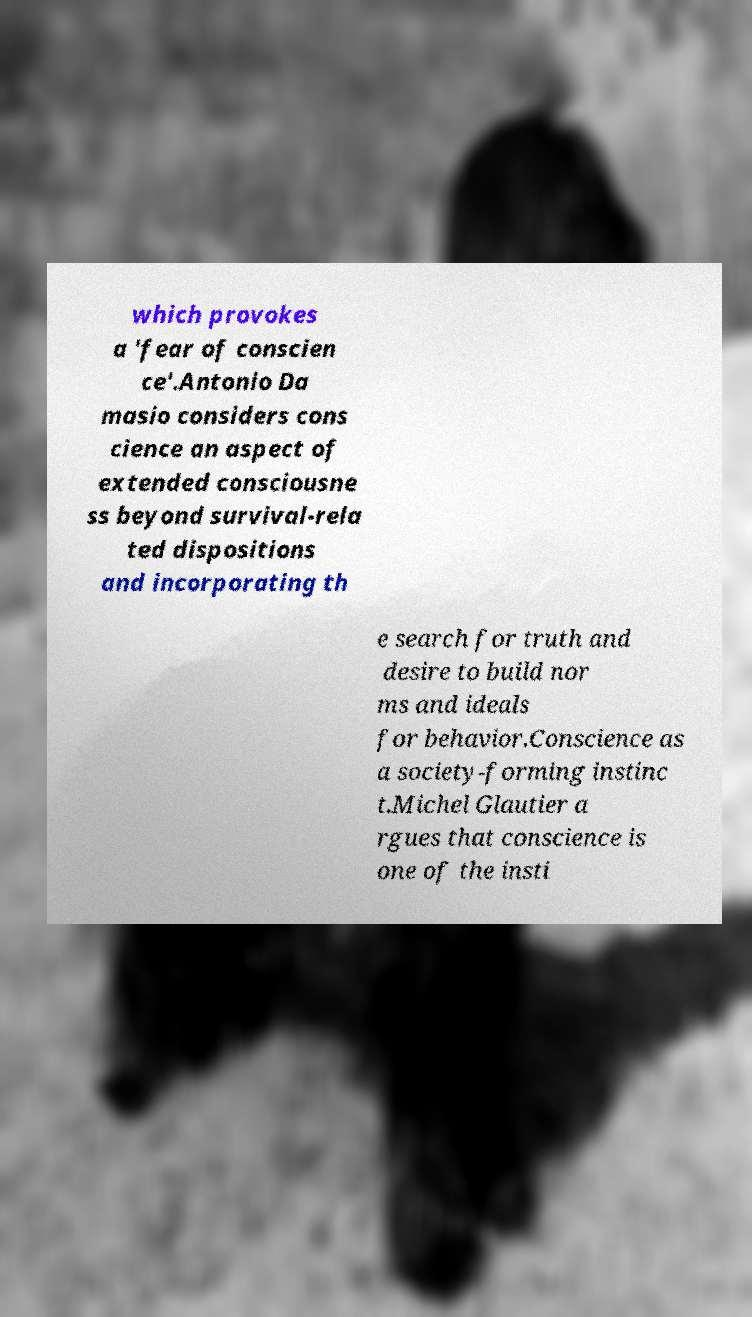Could you extract and type out the text from this image? which provokes a 'fear of conscien ce'.Antonio Da masio considers cons cience an aspect of extended consciousne ss beyond survival-rela ted dispositions and incorporating th e search for truth and desire to build nor ms and ideals for behavior.Conscience as a society-forming instinc t.Michel Glautier a rgues that conscience is one of the insti 